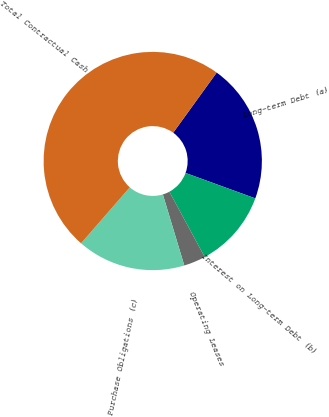<chart> <loc_0><loc_0><loc_500><loc_500><pie_chart><fcel>Long-term Debt (a)<fcel>Interest on Long-term Debt (b)<fcel>Operating Leases<fcel>Purchase Obligations (c)<fcel>Total Contractual Cash<nl><fcel>20.6%<fcel>11.54%<fcel>3.23%<fcel>16.07%<fcel>48.55%<nl></chart> 